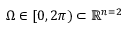<formula> <loc_0><loc_0><loc_500><loc_500>\Omega \in [ 0 , 2 \pi ) \subset \mathbb { R } ^ { n = 2 }</formula> 